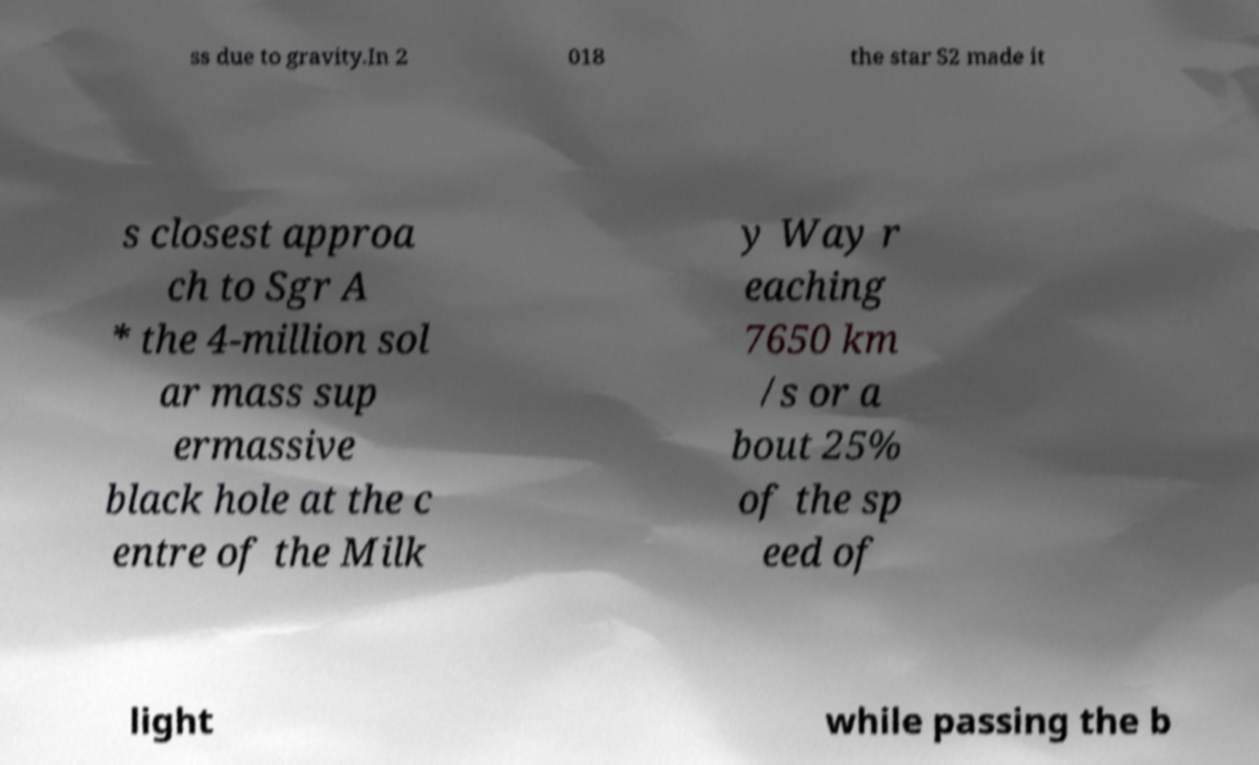Could you assist in decoding the text presented in this image and type it out clearly? ss due to gravity.In 2 018 the star S2 made it s closest approa ch to Sgr A * the 4-million sol ar mass sup ermassive black hole at the c entre of the Milk y Way r eaching 7650 km /s or a bout 25% of the sp eed of light while passing the b 